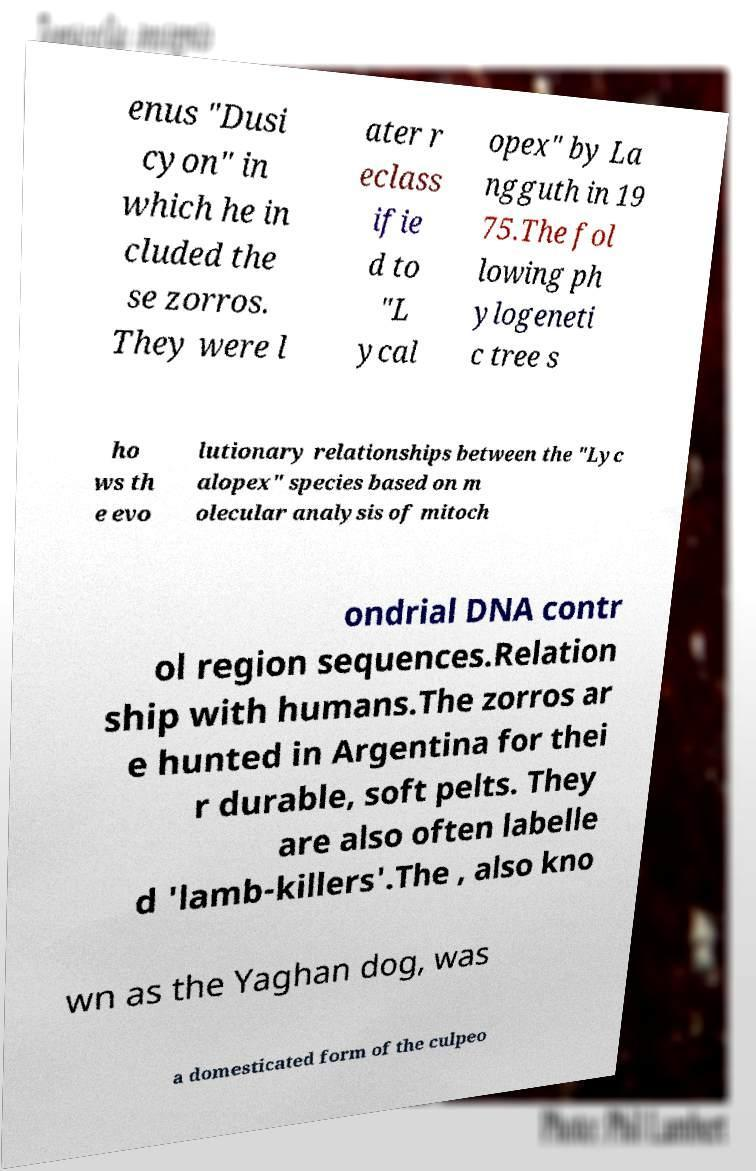Could you extract and type out the text from this image? enus "Dusi cyon" in which he in cluded the se zorros. They were l ater r eclass ifie d to "L ycal opex" by La ngguth in 19 75.The fol lowing ph ylogeneti c tree s ho ws th e evo lutionary relationships between the "Lyc alopex" species based on m olecular analysis of mitoch ondrial DNA contr ol region sequences.Relation ship with humans.The zorros ar e hunted in Argentina for thei r durable, soft pelts. They are also often labelle d 'lamb-killers'.The , also kno wn as the Yaghan dog, was a domesticated form of the culpeo 